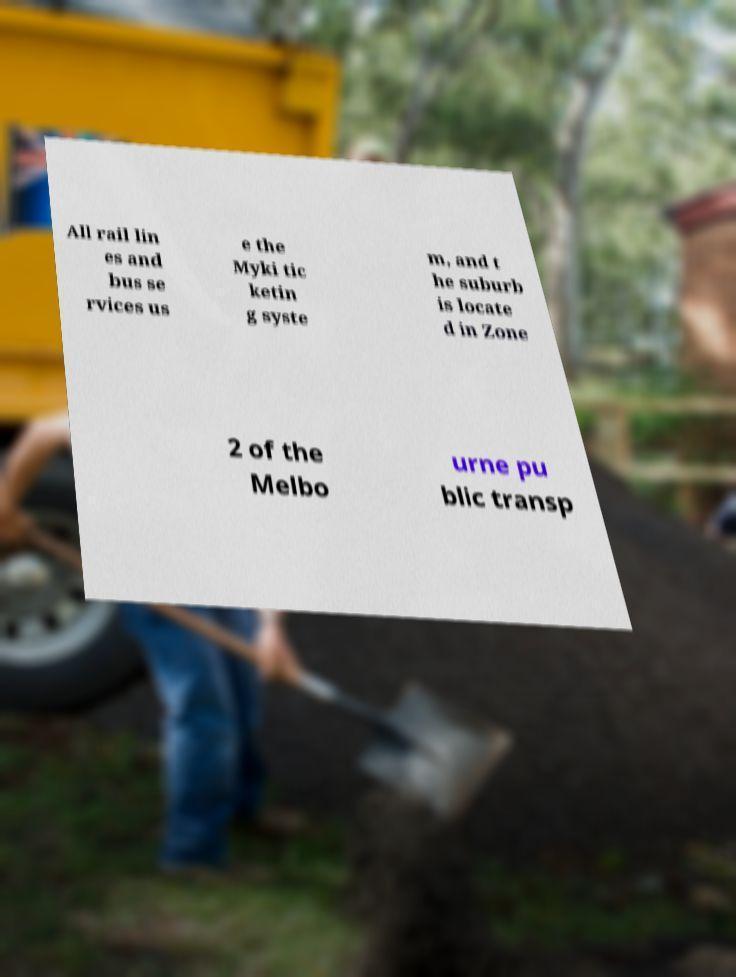There's text embedded in this image that I need extracted. Can you transcribe it verbatim? All rail lin es and bus se rvices us e the Myki tic ketin g syste m, and t he suburb is locate d in Zone 2 of the Melbo urne pu blic transp 